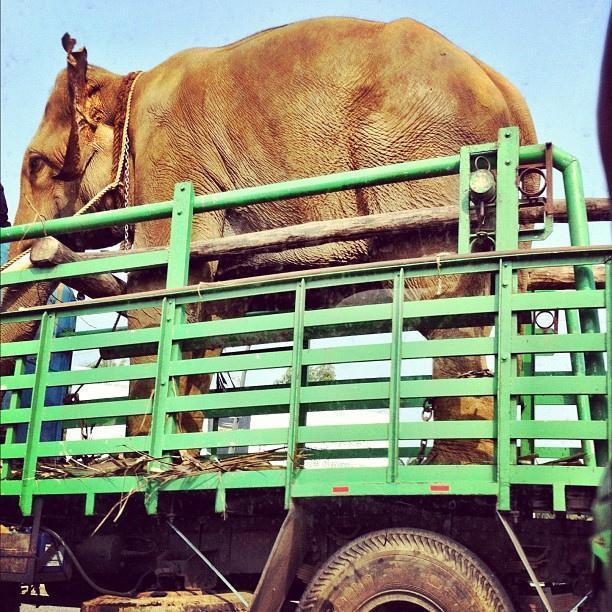Is the caption "The truck is below the elephant." a true representation of the image?
Answer yes or no. Yes. Is "The truck is under the elephant." an appropriate description for the image?
Answer yes or no. Yes. Does the description: "The truck contains the elephant." accurately reflect the image?
Answer yes or no. Yes. 